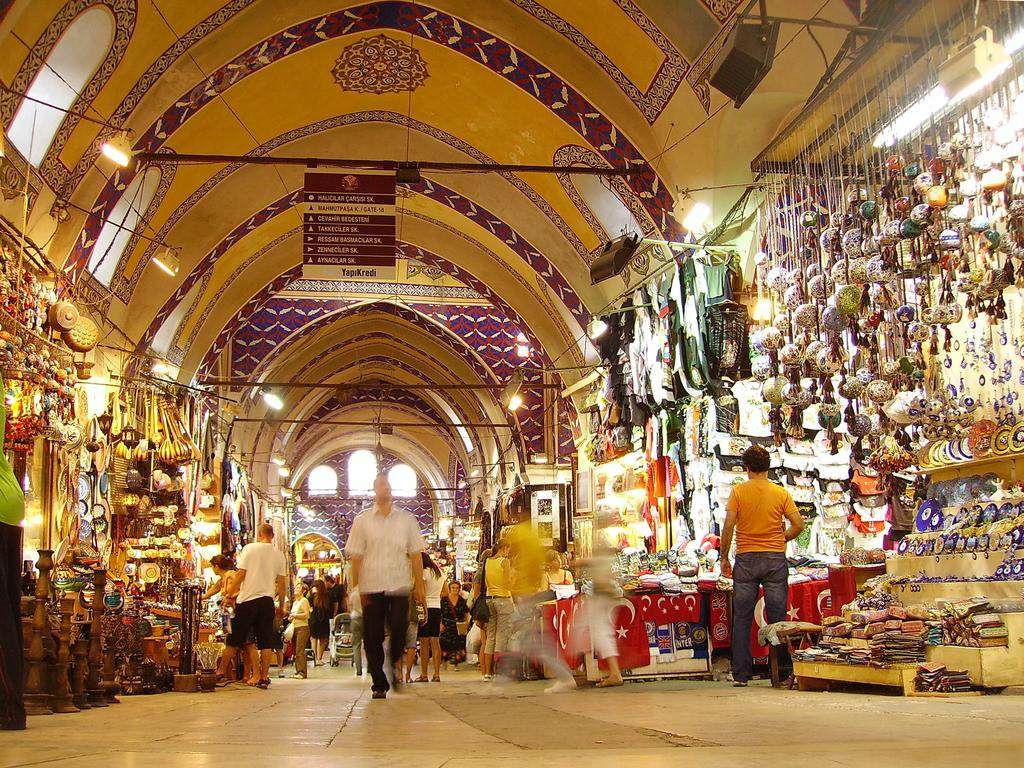What are the people in the image doing? The people in the image are standing and walking. What can be seen in the background of the image? There are stores visible in the background. What is at the top of the image? There is a roof at the top of the image. What objects are present in the image that might be used for support or signage? There are poles and banners in the image. What can be seen that might provide illumination? There are lights in the image. What type of chicken is being served in the image? There is no chicken present in the image. What is the minister doing in the image? There is no minister present in the image. 